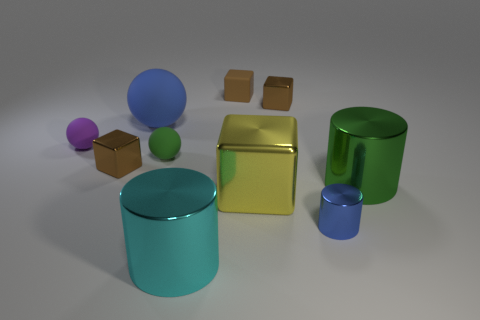Subtract all brown cubes. How many were subtracted if there are2brown cubes left? 1 Subtract all yellow cubes. How many cubes are left? 3 Subtract all yellow spheres. How many brown blocks are left? 3 Subtract all yellow cubes. How many cubes are left? 3 Subtract 1 cylinders. How many cylinders are left? 2 Subtract 0 gray spheres. How many objects are left? 10 Subtract all balls. How many objects are left? 7 Subtract all gray spheres. Subtract all purple cubes. How many spheres are left? 3 Subtract all green rubber spheres. Subtract all tiny objects. How many objects are left? 3 Add 6 brown matte things. How many brown matte things are left? 7 